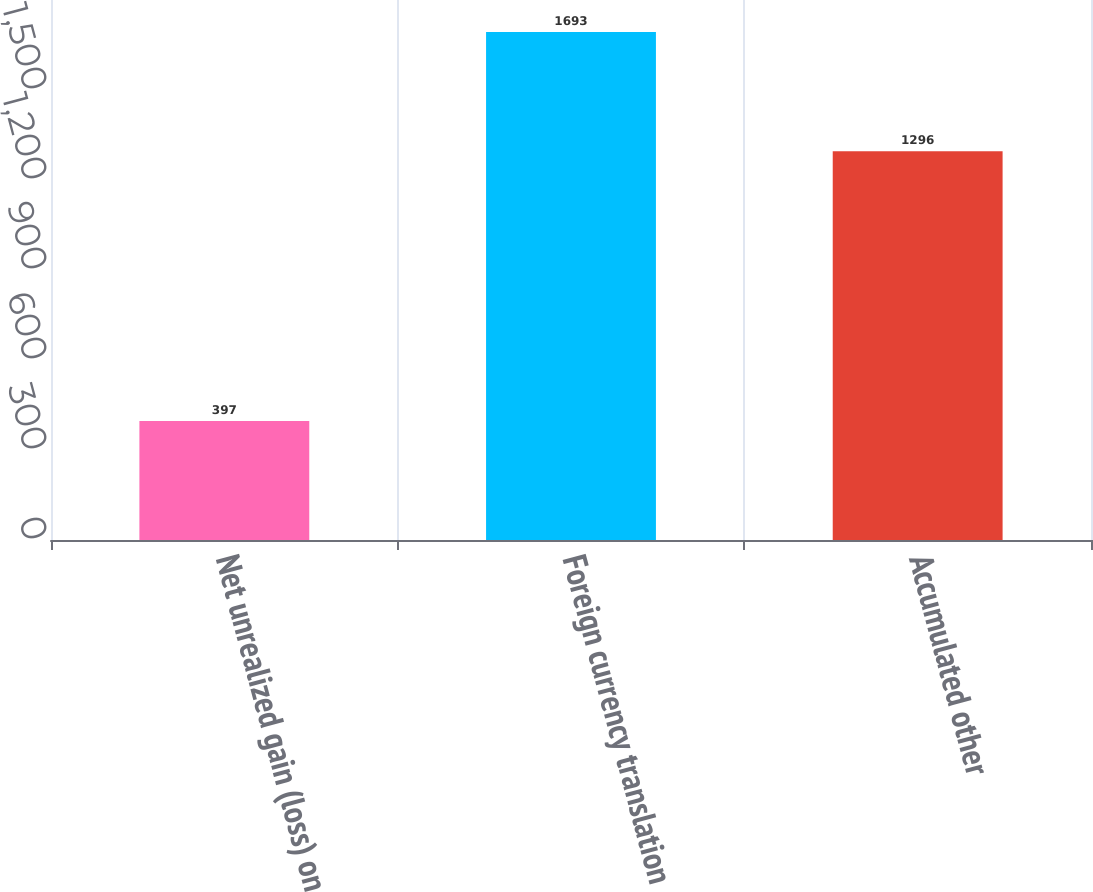<chart> <loc_0><loc_0><loc_500><loc_500><bar_chart><fcel>Net unrealized gain (loss) on<fcel>Foreign currency translation<fcel>Accumulated other<nl><fcel>397<fcel>1693<fcel>1296<nl></chart> 